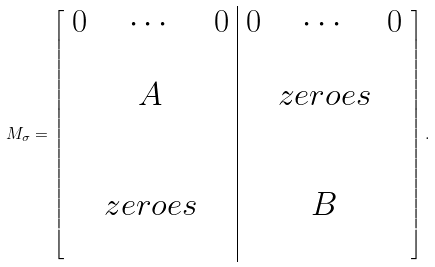<formula> <loc_0><loc_0><loc_500><loc_500>M _ { \sigma } = \left [ \begin{array} { c c c | c c c } 0 & \cdots & 0 & 0 & \cdots & 0 \\ & & & & & \\ & A & & & z e r o e s & \\ & & & & & \\ & & & & & \\ & z e r o e s & & & B & \\ & & & & & \\ \end{array} \right ] .</formula> 